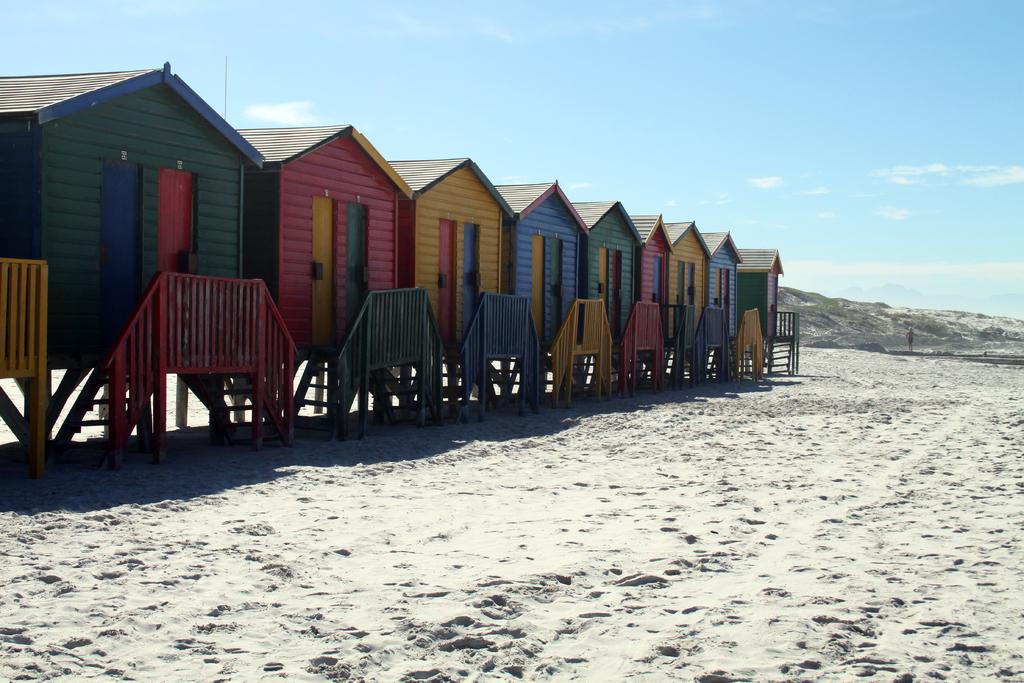Where is the setting of the image? The image is set beside the seashore. What type of houses can be seen in the image? There are houses constructed with wood on the sand. What is the landscape feature visible behind the houses? There is a small mountain behind the houses. How many people are in the crowd gathered around the dinosaurs in the image? There are no people or dinosaurs present in the image; it features houses beside the seashore with a small mountain in the background. 